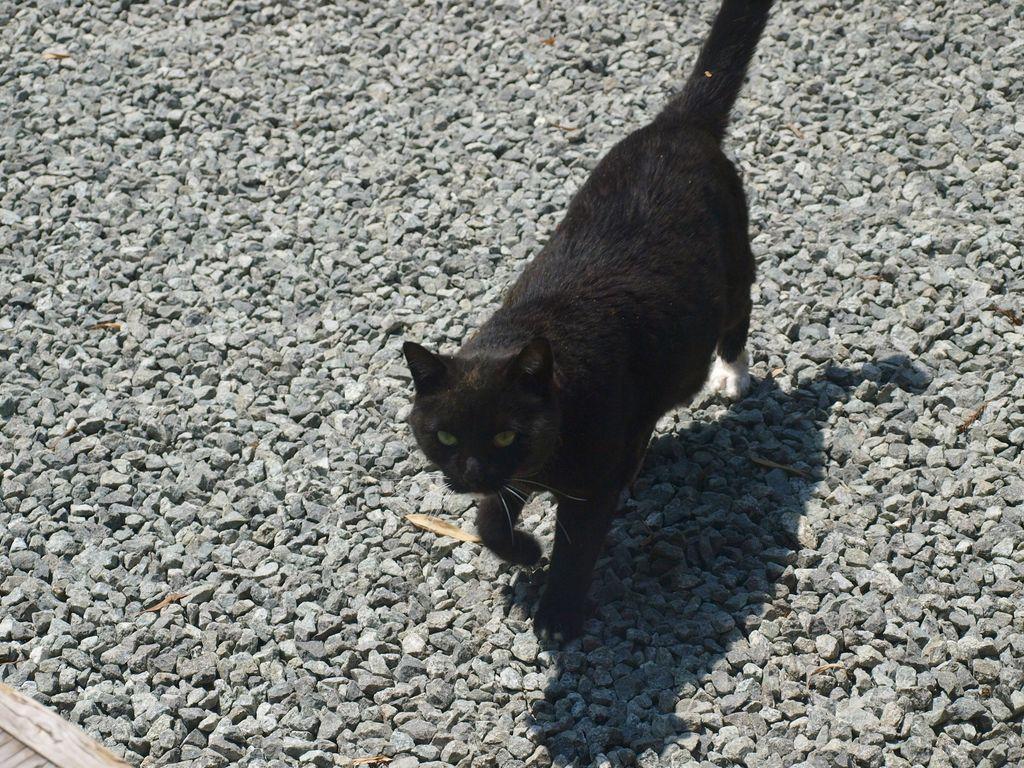Could you give a brief overview of what you see in this image? A black cat is walking on the stones. 